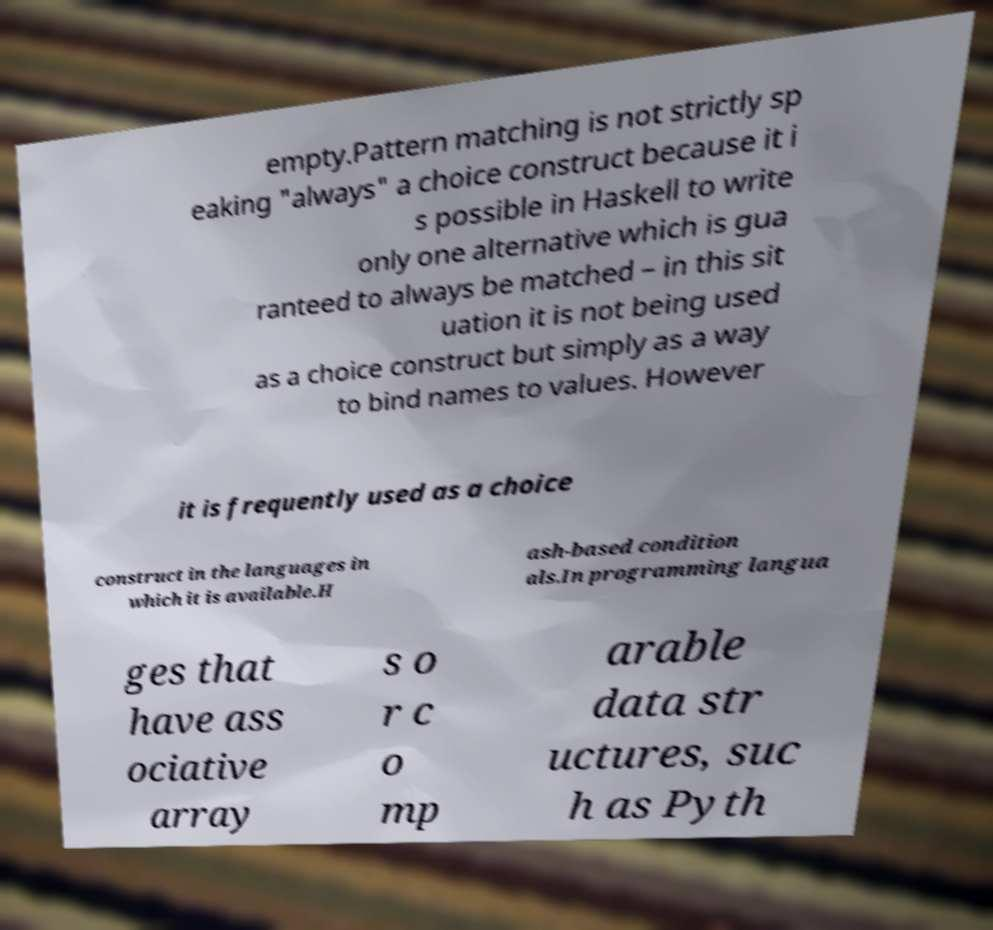For documentation purposes, I need the text within this image transcribed. Could you provide that? empty.Pattern matching is not strictly sp eaking "always" a choice construct because it i s possible in Haskell to write only one alternative which is gua ranteed to always be matched – in this sit uation it is not being used as a choice construct but simply as a way to bind names to values. However it is frequently used as a choice construct in the languages in which it is available.H ash-based condition als.In programming langua ges that have ass ociative array s o r c o mp arable data str uctures, suc h as Pyth 